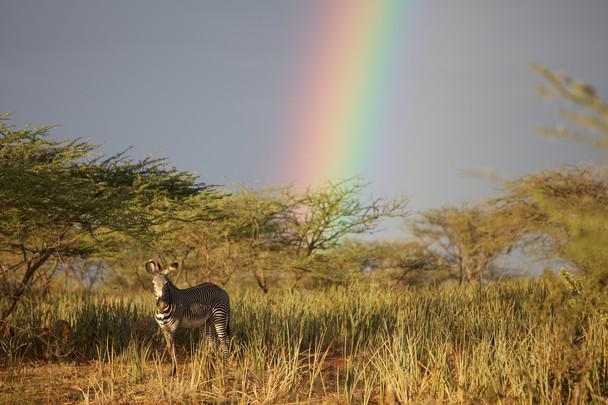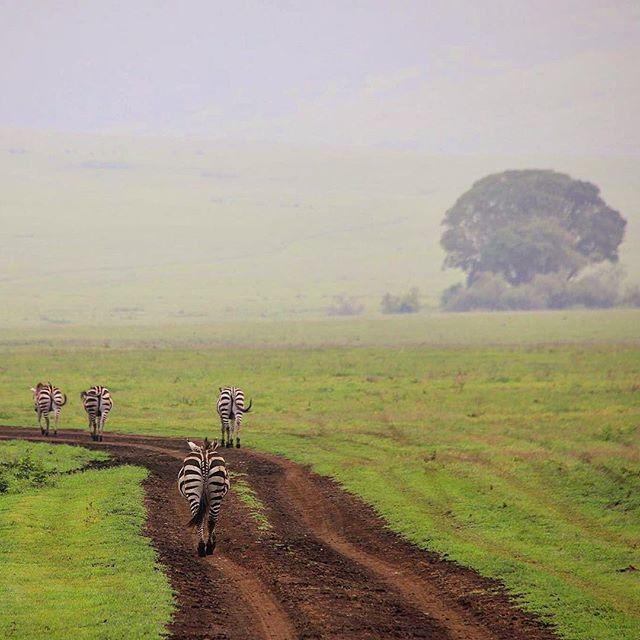The first image is the image on the left, the second image is the image on the right. For the images shown, is this caption "The right image contains no more than five zebras." true? Answer yes or no. Yes. The first image is the image on the left, the second image is the image on the right. Considering the images on both sides, is "There are more than four zebras in each image." valid? Answer yes or no. No. 